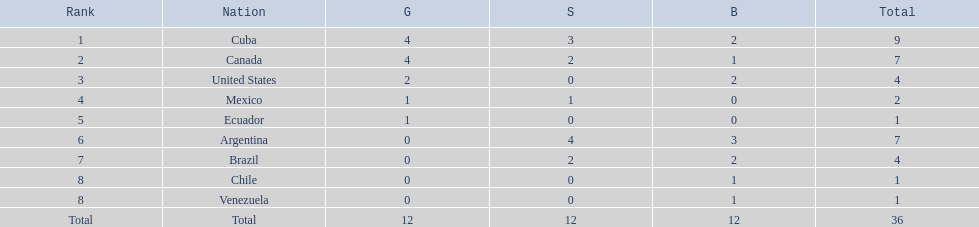Which countries have won gold medals? Cuba, Canada, United States, Mexico, Ecuador. Of these countries, which ones have never won silver or bronze medals? United States, Ecuador. Of the two nations listed previously, which one has only won a gold medal? Ecuador. 